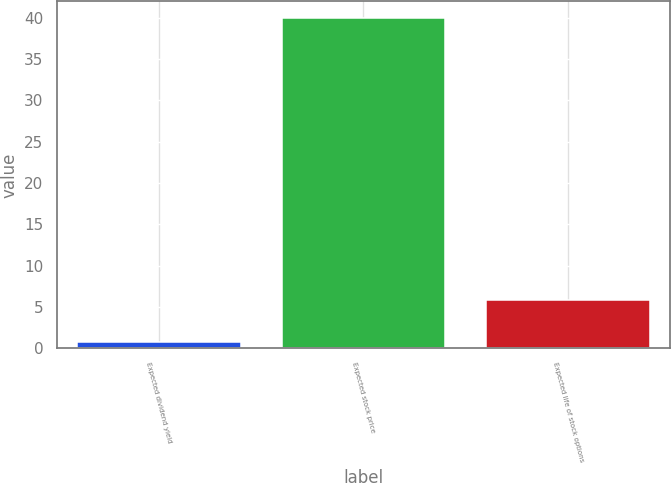<chart> <loc_0><loc_0><loc_500><loc_500><bar_chart><fcel>Expected dividend yield<fcel>Expected stock price<fcel>Expected life of stock options<nl><fcel>0.8<fcel>40<fcel>5.9<nl></chart> 